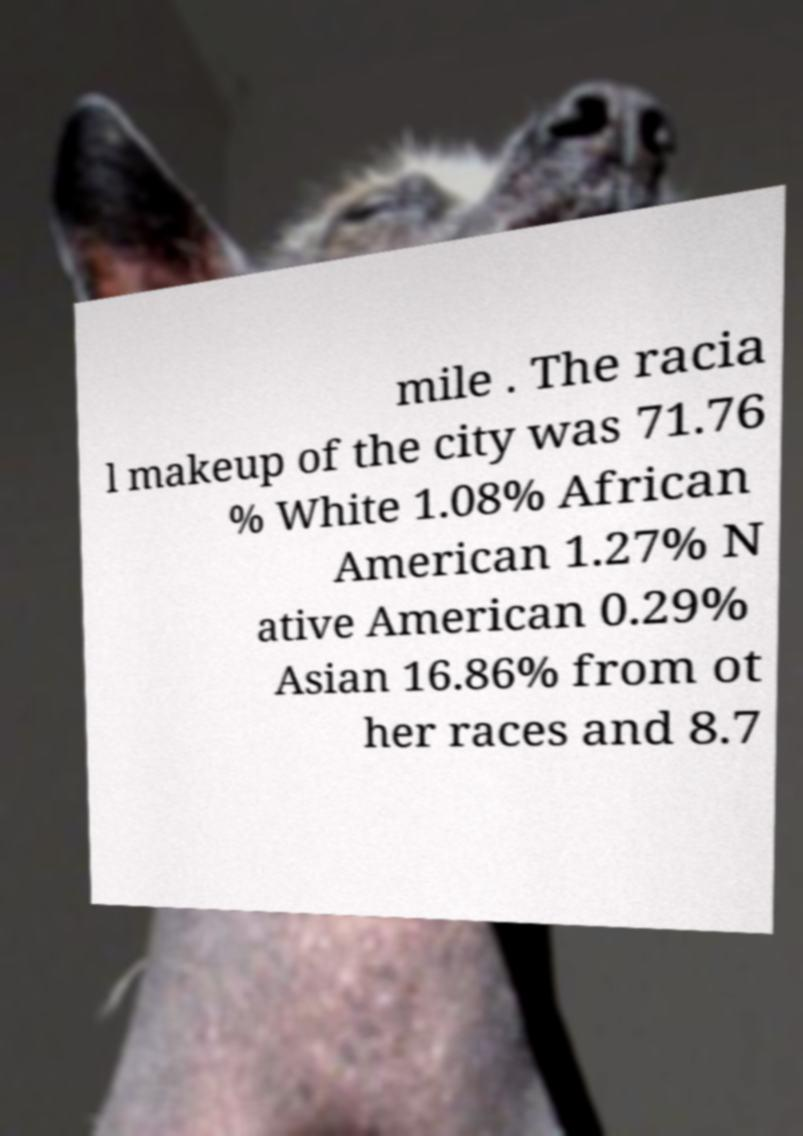Could you extract and type out the text from this image? mile . The racia l makeup of the city was 71.76 % White 1.08% African American 1.27% N ative American 0.29% Asian 16.86% from ot her races and 8.7 